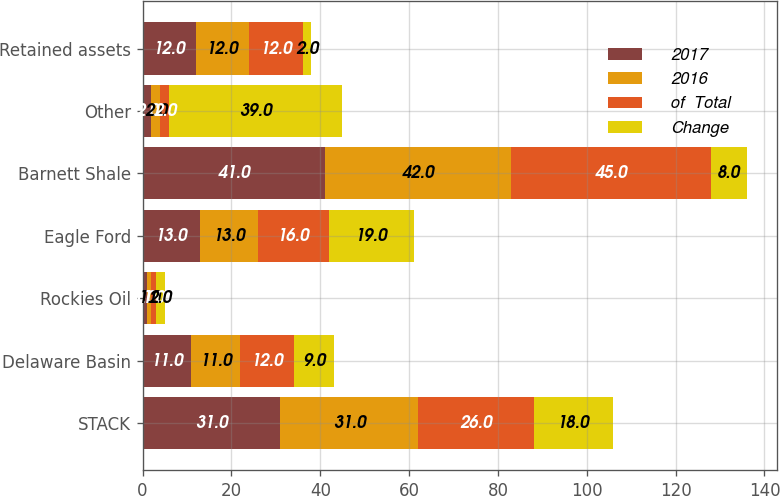Convert chart. <chart><loc_0><loc_0><loc_500><loc_500><stacked_bar_chart><ecel><fcel>STACK<fcel>Delaware Basin<fcel>Rockies Oil<fcel>Eagle Ford<fcel>Barnett Shale<fcel>Other<fcel>Retained assets<nl><fcel>2017<fcel>31<fcel>11<fcel>1<fcel>13<fcel>41<fcel>2<fcel>12<nl><fcel>2016<fcel>31<fcel>11<fcel>1<fcel>13<fcel>42<fcel>2<fcel>12<nl><fcel>of  Total<fcel>26<fcel>12<fcel>1<fcel>16<fcel>45<fcel>2<fcel>12<nl><fcel>Change<fcel>18<fcel>9<fcel>2<fcel>19<fcel>8<fcel>39<fcel>2<nl></chart> 